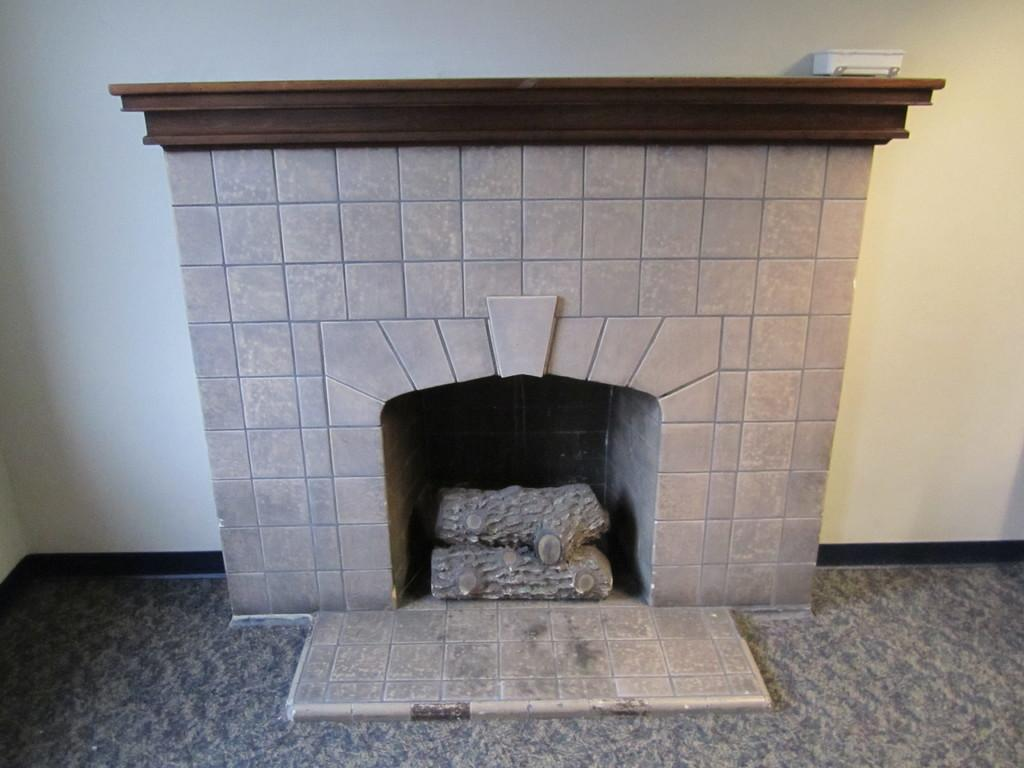What type of surface is visible in the image? The image contains a floor. What objects can be seen on the floor in the image? There are wooden logs in the image. What feature is present in the room in the image? There is a fireplace in the image. What color is the object in the image? There is a white object in the image. What can be seen in the background of the image? There is a wall visible in the background of the image. Can you see the father playing with a goldfish in the image? There is no father or goldfish present in the image. Is there a giraffe visible in the image? There is no giraffe present in the image. 